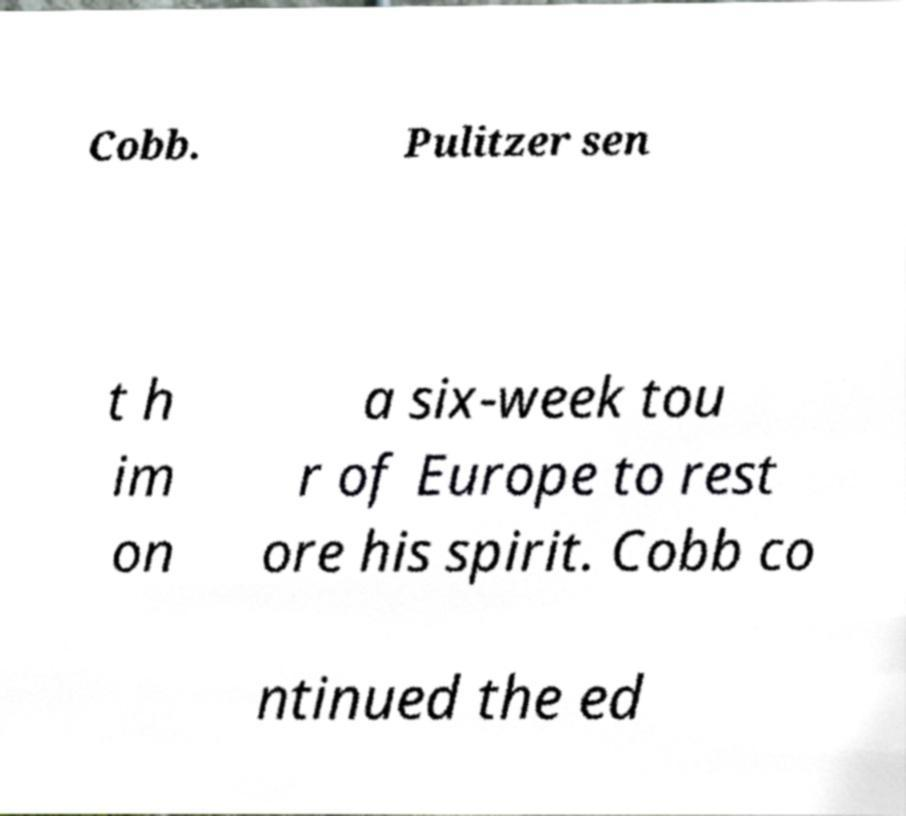Can you read and provide the text displayed in the image?This photo seems to have some interesting text. Can you extract and type it out for me? Cobb. Pulitzer sen t h im on a six-week tou r of Europe to rest ore his spirit. Cobb co ntinued the ed 